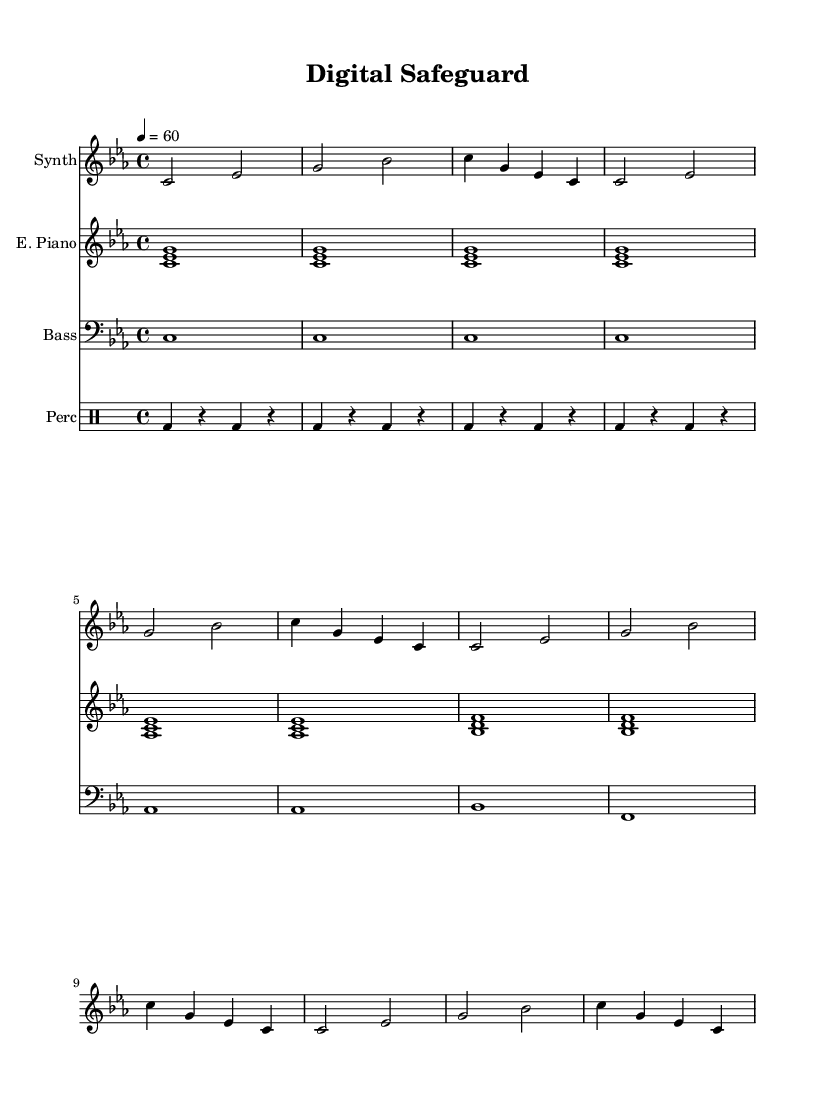What is the key signature of this music? The key signature is C minor, which has three flats: B flat, E flat, and A flat. You can determine this by looking at the key signature area on the left side of the sheet music.
Answer: C minor What is the time signature of this piece? The time signature is 4/4, which means there are four beats in each measure and the quarter note gets one beat. This is indicated at the beginning of the score below the clef.
Answer: 4/4 What is the tempo marking for the piece? The tempo marking is a quarter note equals 60 beats per minute, which is indicated after the time signature at the beginning of the piece.
Answer: 60 How many measures are in the synthesizer part? The synthesizer part contains eight measures, which can be counted by identifying the vertical bar lines that separate each measure in the staff.
Answer: 8 What is the predominant instrument in this composition? The predominant instrument in this composition is the synthesizer, as it leads the melody and is notated on the staff above the piano part.
Answer: Synthesizer What comprises the harmonic support in this piece? The harmonic support is provided by the electric piano, which plays chords throughout the piece, and the bass, which provides a foundation. This can be seen from the staff where the electric piano and bass are notated.
Answer: Electric piano and bass What style of music is represented by this sheet? The style of music represented is ambient electronic, which is characterized by electronic instruments and synthesizers, creating a calm and focused atmosphere. This can be inferred from the instrumentation and the overall sound typically associated with ambient music.
Answer: Ambient electronic 